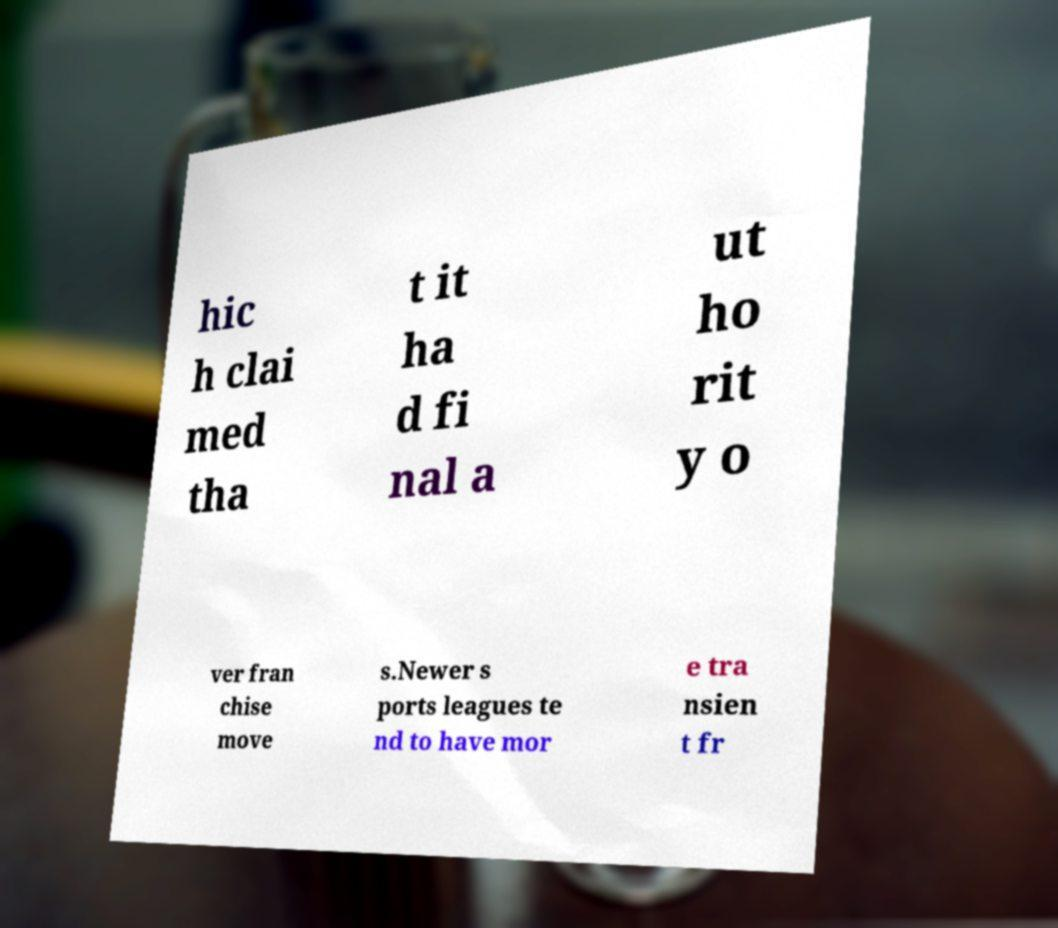Please read and relay the text visible in this image. What does it say? hic h clai med tha t it ha d fi nal a ut ho rit y o ver fran chise move s.Newer s ports leagues te nd to have mor e tra nsien t fr 